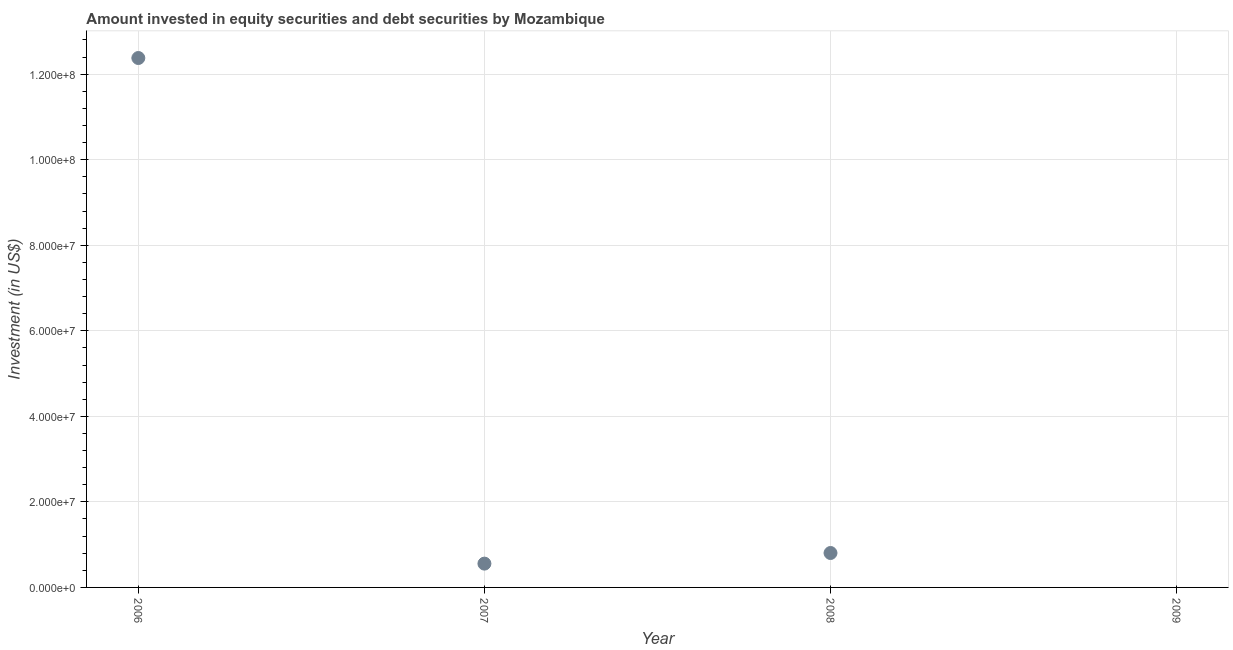What is the portfolio investment in 2006?
Your response must be concise. 1.24e+08. Across all years, what is the maximum portfolio investment?
Your response must be concise. 1.24e+08. Across all years, what is the minimum portfolio investment?
Offer a terse response. 0. What is the sum of the portfolio investment?
Keep it short and to the point. 1.37e+08. What is the difference between the portfolio investment in 2006 and 2008?
Your response must be concise. 1.16e+08. What is the average portfolio investment per year?
Provide a succinct answer. 3.43e+07. What is the median portfolio investment?
Provide a succinct answer. 6.81e+06. In how many years, is the portfolio investment greater than 8000000 US$?
Your answer should be compact. 2. What is the ratio of the portfolio investment in 2007 to that in 2008?
Your answer should be compact. 0.69. Is the difference between the portfolio investment in 2006 and 2007 greater than the difference between any two years?
Make the answer very short. No. What is the difference between the highest and the second highest portfolio investment?
Make the answer very short. 1.16e+08. Is the sum of the portfolio investment in 2006 and 2007 greater than the maximum portfolio investment across all years?
Offer a very short reply. Yes. What is the difference between the highest and the lowest portfolio investment?
Offer a very short reply. 1.24e+08. How many dotlines are there?
Make the answer very short. 1. Does the graph contain grids?
Your answer should be very brief. Yes. What is the title of the graph?
Provide a short and direct response. Amount invested in equity securities and debt securities by Mozambique. What is the label or title of the X-axis?
Ensure brevity in your answer.  Year. What is the label or title of the Y-axis?
Keep it short and to the point. Investment (in US$). What is the Investment (in US$) in 2006?
Give a very brief answer. 1.24e+08. What is the Investment (in US$) in 2007?
Your answer should be compact. 5.57e+06. What is the Investment (in US$) in 2008?
Provide a short and direct response. 8.05e+06. What is the difference between the Investment (in US$) in 2006 and 2007?
Provide a succinct answer. 1.18e+08. What is the difference between the Investment (in US$) in 2006 and 2008?
Make the answer very short. 1.16e+08. What is the difference between the Investment (in US$) in 2007 and 2008?
Provide a short and direct response. -2.48e+06. What is the ratio of the Investment (in US$) in 2006 to that in 2007?
Offer a terse response. 22.24. What is the ratio of the Investment (in US$) in 2006 to that in 2008?
Keep it short and to the point. 15.38. What is the ratio of the Investment (in US$) in 2007 to that in 2008?
Keep it short and to the point. 0.69. 